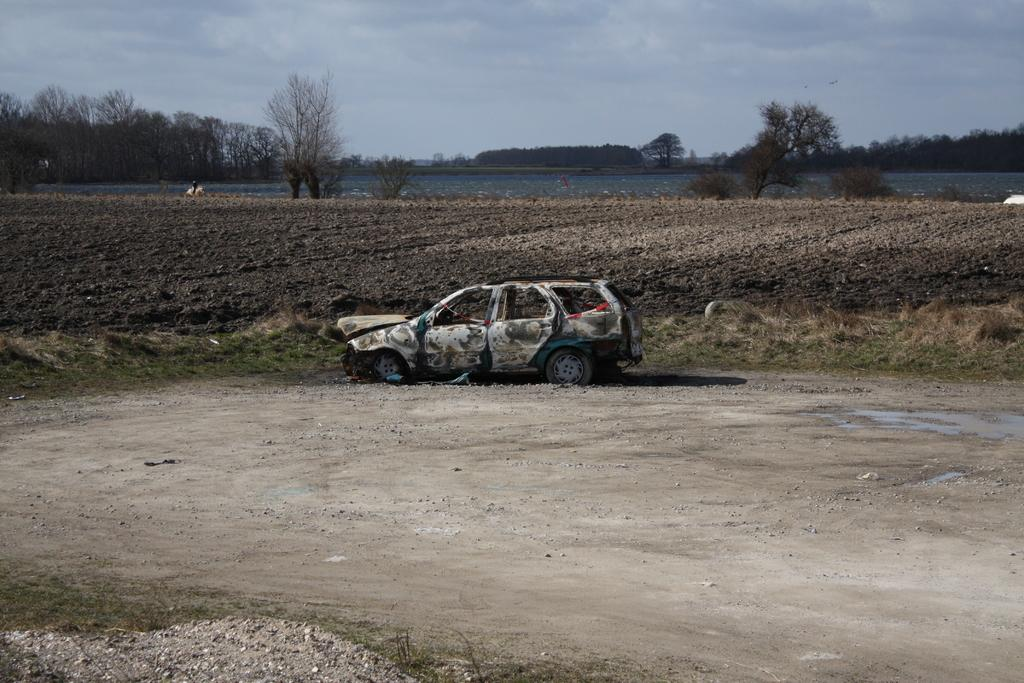What is the main subject of the image? The main subject of the image is a vehicle. What type of natural elements can be seen in the image? There are stones, grass, trees, and water visible in the image. What part of the natural environment is visible in the image? The sky is visible in the image. Can you touch the celery in the image? There is no celery present in the image, so it cannot be touched. What type of design is featured on the vehicle in the image? The provided facts do not mention any specific design on the vehicle, so it cannot be determined from the image. 